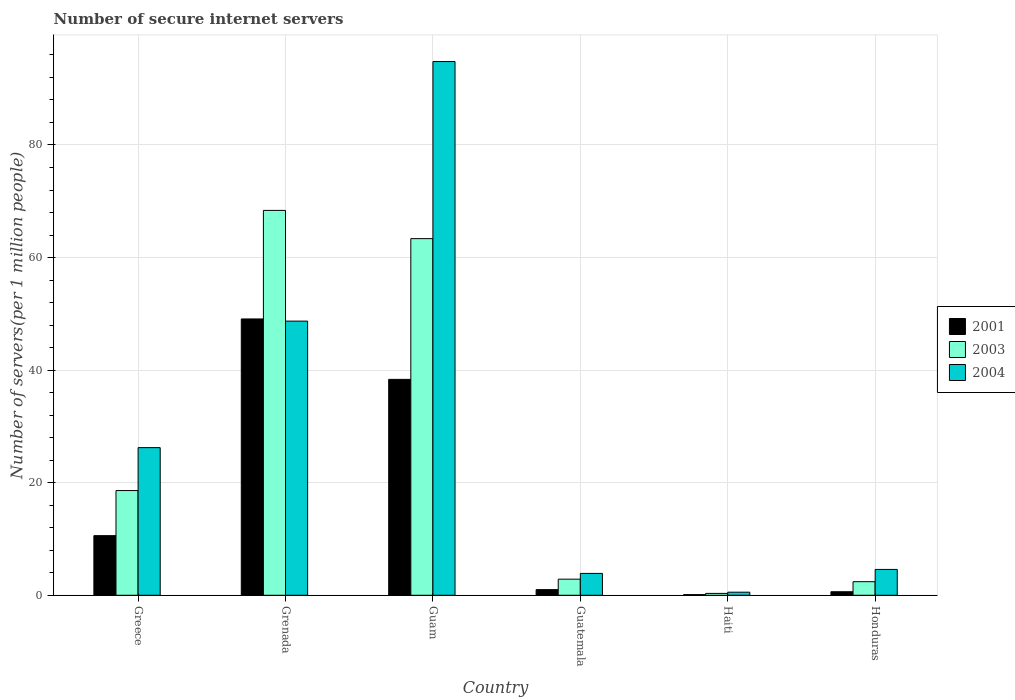Are the number of bars per tick equal to the number of legend labels?
Keep it short and to the point. Yes. Are the number of bars on each tick of the X-axis equal?
Make the answer very short. Yes. How many bars are there on the 4th tick from the left?
Provide a short and direct response. 3. How many bars are there on the 5th tick from the right?
Your response must be concise. 3. What is the label of the 3rd group of bars from the left?
Give a very brief answer. Guam. What is the number of secure internet servers in 2004 in Grenada?
Your answer should be very brief. 48.71. Across all countries, what is the maximum number of secure internet servers in 2001?
Offer a very short reply. 49.09. Across all countries, what is the minimum number of secure internet servers in 2001?
Provide a succinct answer. 0.12. In which country was the number of secure internet servers in 2001 maximum?
Offer a terse response. Grenada. In which country was the number of secure internet servers in 2004 minimum?
Your answer should be compact. Haiti. What is the total number of secure internet servers in 2004 in the graph?
Your response must be concise. 178.78. What is the difference between the number of secure internet servers in 2004 in Greece and that in Guam?
Your answer should be compact. -68.59. What is the difference between the number of secure internet servers in 2003 in Grenada and the number of secure internet servers in 2001 in Guam?
Your response must be concise. 30.02. What is the average number of secure internet servers in 2003 per country?
Offer a terse response. 25.99. What is the difference between the number of secure internet servers of/in 2003 and number of secure internet servers of/in 2001 in Guam?
Ensure brevity in your answer.  25. What is the ratio of the number of secure internet servers in 2001 in Haiti to that in Honduras?
Offer a very short reply. 0.18. Is the number of secure internet servers in 2004 in Grenada less than that in Guam?
Keep it short and to the point. Yes. What is the difference between the highest and the second highest number of secure internet servers in 2001?
Provide a succinct answer. 38.5. What is the difference between the highest and the lowest number of secure internet servers in 2003?
Give a very brief answer. 68.04. In how many countries, is the number of secure internet servers in 2003 greater than the average number of secure internet servers in 2003 taken over all countries?
Your answer should be compact. 2. Is the sum of the number of secure internet servers in 2003 in Guatemala and Haiti greater than the maximum number of secure internet servers in 2004 across all countries?
Provide a short and direct response. No. What does the 3rd bar from the left in Guatemala represents?
Your answer should be compact. 2004. What does the 2nd bar from the right in Guatemala represents?
Your response must be concise. 2003. What is the difference between two consecutive major ticks on the Y-axis?
Offer a terse response. 20. Are the values on the major ticks of Y-axis written in scientific E-notation?
Your answer should be compact. No. Where does the legend appear in the graph?
Make the answer very short. Center right. How many legend labels are there?
Offer a terse response. 3. How are the legend labels stacked?
Your answer should be compact. Vertical. What is the title of the graph?
Your answer should be very brief. Number of secure internet servers. What is the label or title of the X-axis?
Provide a succinct answer. Country. What is the label or title of the Y-axis?
Your answer should be very brief. Number of servers(per 1 million people). What is the Number of servers(per 1 million people) in 2001 in Greece?
Your response must be concise. 10.59. What is the Number of servers(per 1 million people) of 2003 in Greece?
Offer a terse response. 18.61. What is the Number of servers(per 1 million people) in 2004 in Greece?
Your response must be concise. 26.23. What is the Number of servers(per 1 million people) of 2001 in Grenada?
Ensure brevity in your answer.  49.09. What is the Number of servers(per 1 million people) of 2003 in Grenada?
Offer a terse response. 68.38. What is the Number of servers(per 1 million people) of 2004 in Grenada?
Keep it short and to the point. 48.71. What is the Number of servers(per 1 million people) of 2001 in Guam?
Your answer should be very brief. 38.36. What is the Number of servers(per 1 million people) in 2003 in Guam?
Ensure brevity in your answer.  63.36. What is the Number of servers(per 1 million people) of 2004 in Guam?
Your response must be concise. 94.82. What is the Number of servers(per 1 million people) in 2001 in Guatemala?
Offer a terse response. 1. What is the Number of servers(per 1 million people) of 2003 in Guatemala?
Your answer should be very brief. 2.86. What is the Number of servers(per 1 million people) of 2004 in Guatemala?
Provide a succinct answer. 3.88. What is the Number of servers(per 1 million people) of 2001 in Haiti?
Give a very brief answer. 0.12. What is the Number of servers(per 1 million people) of 2003 in Haiti?
Give a very brief answer. 0.33. What is the Number of servers(per 1 million people) of 2004 in Haiti?
Your answer should be very brief. 0.55. What is the Number of servers(per 1 million people) in 2001 in Honduras?
Make the answer very short. 0.63. What is the Number of servers(per 1 million people) of 2003 in Honduras?
Give a very brief answer. 2.41. What is the Number of servers(per 1 million people) in 2004 in Honduras?
Provide a succinct answer. 4.59. Across all countries, what is the maximum Number of servers(per 1 million people) in 2001?
Make the answer very short. 49.09. Across all countries, what is the maximum Number of servers(per 1 million people) in 2003?
Offer a very short reply. 68.38. Across all countries, what is the maximum Number of servers(per 1 million people) of 2004?
Give a very brief answer. 94.82. Across all countries, what is the minimum Number of servers(per 1 million people) in 2001?
Give a very brief answer. 0.12. Across all countries, what is the minimum Number of servers(per 1 million people) of 2003?
Make the answer very short. 0.33. Across all countries, what is the minimum Number of servers(per 1 million people) in 2004?
Offer a terse response. 0.55. What is the total Number of servers(per 1 million people) of 2001 in the graph?
Keep it short and to the point. 99.79. What is the total Number of servers(per 1 million people) of 2003 in the graph?
Make the answer very short. 155.96. What is the total Number of servers(per 1 million people) of 2004 in the graph?
Keep it short and to the point. 178.78. What is the difference between the Number of servers(per 1 million people) of 2001 in Greece and that in Grenada?
Your response must be concise. -38.5. What is the difference between the Number of servers(per 1 million people) of 2003 in Greece and that in Grenada?
Ensure brevity in your answer.  -49.77. What is the difference between the Number of servers(per 1 million people) of 2004 in Greece and that in Grenada?
Offer a terse response. -22.48. What is the difference between the Number of servers(per 1 million people) in 2001 in Greece and that in Guam?
Give a very brief answer. -27.77. What is the difference between the Number of servers(per 1 million people) of 2003 in Greece and that in Guam?
Ensure brevity in your answer.  -44.76. What is the difference between the Number of servers(per 1 million people) of 2004 in Greece and that in Guam?
Your response must be concise. -68.59. What is the difference between the Number of servers(per 1 million people) in 2001 in Greece and that in Guatemala?
Ensure brevity in your answer.  9.59. What is the difference between the Number of servers(per 1 million people) of 2003 in Greece and that in Guatemala?
Offer a terse response. 15.74. What is the difference between the Number of servers(per 1 million people) in 2004 in Greece and that in Guatemala?
Ensure brevity in your answer.  22.35. What is the difference between the Number of servers(per 1 million people) in 2001 in Greece and that in Haiti?
Make the answer very short. 10.48. What is the difference between the Number of servers(per 1 million people) in 2003 in Greece and that in Haiti?
Ensure brevity in your answer.  18.27. What is the difference between the Number of servers(per 1 million people) in 2004 in Greece and that in Haiti?
Keep it short and to the point. 25.68. What is the difference between the Number of servers(per 1 million people) in 2001 in Greece and that in Honduras?
Provide a succinct answer. 9.96. What is the difference between the Number of servers(per 1 million people) in 2003 in Greece and that in Honduras?
Offer a very short reply. 16.19. What is the difference between the Number of servers(per 1 million people) in 2004 in Greece and that in Honduras?
Make the answer very short. 21.64. What is the difference between the Number of servers(per 1 million people) of 2001 in Grenada and that in Guam?
Offer a very short reply. 10.73. What is the difference between the Number of servers(per 1 million people) of 2003 in Grenada and that in Guam?
Provide a short and direct response. 5.02. What is the difference between the Number of servers(per 1 million people) of 2004 in Grenada and that in Guam?
Ensure brevity in your answer.  -46.11. What is the difference between the Number of servers(per 1 million people) in 2001 in Grenada and that in Guatemala?
Offer a terse response. 48.09. What is the difference between the Number of servers(per 1 million people) in 2003 in Grenada and that in Guatemala?
Provide a short and direct response. 65.52. What is the difference between the Number of servers(per 1 million people) in 2004 in Grenada and that in Guatemala?
Your answer should be compact. 44.82. What is the difference between the Number of servers(per 1 million people) of 2001 in Grenada and that in Haiti?
Your response must be concise. 48.98. What is the difference between the Number of servers(per 1 million people) of 2003 in Grenada and that in Haiti?
Give a very brief answer. 68.04. What is the difference between the Number of servers(per 1 million people) of 2004 in Grenada and that in Haiti?
Your answer should be compact. 48.16. What is the difference between the Number of servers(per 1 million people) in 2001 in Grenada and that in Honduras?
Provide a succinct answer. 48.46. What is the difference between the Number of servers(per 1 million people) in 2003 in Grenada and that in Honduras?
Make the answer very short. 65.96. What is the difference between the Number of servers(per 1 million people) of 2004 in Grenada and that in Honduras?
Offer a very short reply. 44.12. What is the difference between the Number of servers(per 1 million people) of 2001 in Guam and that in Guatemala?
Keep it short and to the point. 37.36. What is the difference between the Number of servers(per 1 million people) in 2003 in Guam and that in Guatemala?
Provide a short and direct response. 60.5. What is the difference between the Number of servers(per 1 million people) in 2004 in Guam and that in Guatemala?
Your answer should be very brief. 90.94. What is the difference between the Number of servers(per 1 million people) in 2001 in Guam and that in Haiti?
Provide a short and direct response. 38.24. What is the difference between the Number of servers(per 1 million people) in 2003 in Guam and that in Haiti?
Keep it short and to the point. 63.03. What is the difference between the Number of servers(per 1 million people) of 2004 in Guam and that in Haiti?
Ensure brevity in your answer.  94.27. What is the difference between the Number of servers(per 1 million people) in 2001 in Guam and that in Honduras?
Provide a short and direct response. 37.73. What is the difference between the Number of servers(per 1 million people) of 2003 in Guam and that in Honduras?
Make the answer very short. 60.95. What is the difference between the Number of servers(per 1 million people) of 2004 in Guam and that in Honduras?
Keep it short and to the point. 90.23. What is the difference between the Number of servers(per 1 million people) of 2001 in Guatemala and that in Haiti?
Provide a succinct answer. 0.89. What is the difference between the Number of servers(per 1 million people) in 2003 in Guatemala and that in Haiti?
Provide a succinct answer. 2.53. What is the difference between the Number of servers(per 1 million people) of 2004 in Guatemala and that in Haiti?
Offer a terse response. 3.33. What is the difference between the Number of servers(per 1 million people) in 2001 in Guatemala and that in Honduras?
Your answer should be very brief. 0.37. What is the difference between the Number of servers(per 1 million people) in 2003 in Guatemala and that in Honduras?
Give a very brief answer. 0.45. What is the difference between the Number of servers(per 1 million people) in 2004 in Guatemala and that in Honduras?
Make the answer very short. -0.71. What is the difference between the Number of servers(per 1 million people) in 2001 in Haiti and that in Honduras?
Your answer should be very brief. -0.51. What is the difference between the Number of servers(per 1 million people) in 2003 in Haiti and that in Honduras?
Ensure brevity in your answer.  -2.08. What is the difference between the Number of servers(per 1 million people) of 2004 in Haiti and that in Honduras?
Give a very brief answer. -4.04. What is the difference between the Number of servers(per 1 million people) of 2001 in Greece and the Number of servers(per 1 million people) of 2003 in Grenada?
Provide a succinct answer. -57.79. What is the difference between the Number of servers(per 1 million people) in 2001 in Greece and the Number of servers(per 1 million people) in 2004 in Grenada?
Offer a terse response. -38.11. What is the difference between the Number of servers(per 1 million people) of 2003 in Greece and the Number of servers(per 1 million people) of 2004 in Grenada?
Ensure brevity in your answer.  -30.1. What is the difference between the Number of servers(per 1 million people) of 2001 in Greece and the Number of servers(per 1 million people) of 2003 in Guam?
Your answer should be very brief. -52.77. What is the difference between the Number of servers(per 1 million people) of 2001 in Greece and the Number of servers(per 1 million people) of 2004 in Guam?
Provide a short and direct response. -84.23. What is the difference between the Number of servers(per 1 million people) in 2003 in Greece and the Number of servers(per 1 million people) in 2004 in Guam?
Offer a terse response. -76.21. What is the difference between the Number of servers(per 1 million people) in 2001 in Greece and the Number of servers(per 1 million people) in 2003 in Guatemala?
Give a very brief answer. 7.73. What is the difference between the Number of servers(per 1 million people) in 2001 in Greece and the Number of servers(per 1 million people) in 2004 in Guatemala?
Offer a very short reply. 6.71. What is the difference between the Number of servers(per 1 million people) of 2003 in Greece and the Number of servers(per 1 million people) of 2004 in Guatemala?
Your answer should be compact. 14.72. What is the difference between the Number of servers(per 1 million people) of 2001 in Greece and the Number of servers(per 1 million people) of 2003 in Haiti?
Your answer should be very brief. 10.26. What is the difference between the Number of servers(per 1 million people) of 2001 in Greece and the Number of servers(per 1 million people) of 2004 in Haiti?
Keep it short and to the point. 10.04. What is the difference between the Number of servers(per 1 million people) of 2003 in Greece and the Number of servers(per 1 million people) of 2004 in Haiti?
Keep it short and to the point. 18.06. What is the difference between the Number of servers(per 1 million people) of 2001 in Greece and the Number of servers(per 1 million people) of 2003 in Honduras?
Offer a very short reply. 8.18. What is the difference between the Number of servers(per 1 million people) of 2001 in Greece and the Number of servers(per 1 million people) of 2004 in Honduras?
Provide a short and direct response. 6. What is the difference between the Number of servers(per 1 million people) in 2003 in Greece and the Number of servers(per 1 million people) in 2004 in Honduras?
Your response must be concise. 14.02. What is the difference between the Number of servers(per 1 million people) in 2001 in Grenada and the Number of servers(per 1 million people) in 2003 in Guam?
Your response must be concise. -14.27. What is the difference between the Number of servers(per 1 million people) in 2001 in Grenada and the Number of servers(per 1 million people) in 2004 in Guam?
Provide a short and direct response. -45.73. What is the difference between the Number of servers(per 1 million people) of 2003 in Grenada and the Number of servers(per 1 million people) of 2004 in Guam?
Offer a terse response. -26.44. What is the difference between the Number of servers(per 1 million people) of 2001 in Grenada and the Number of servers(per 1 million people) of 2003 in Guatemala?
Make the answer very short. 46.23. What is the difference between the Number of servers(per 1 million people) in 2001 in Grenada and the Number of servers(per 1 million people) in 2004 in Guatemala?
Keep it short and to the point. 45.21. What is the difference between the Number of servers(per 1 million people) in 2003 in Grenada and the Number of servers(per 1 million people) in 2004 in Guatemala?
Offer a terse response. 64.5. What is the difference between the Number of servers(per 1 million people) of 2001 in Grenada and the Number of servers(per 1 million people) of 2003 in Haiti?
Ensure brevity in your answer.  48.76. What is the difference between the Number of servers(per 1 million people) of 2001 in Grenada and the Number of servers(per 1 million people) of 2004 in Haiti?
Make the answer very short. 48.54. What is the difference between the Number of servers(per 1 million people) in 2003 in Grenada and the Number of servers(per 1 million people) in 2004 in Haiti?
Give a very brief answer. 67.83. What is the difference between the Number of servers(per 1 million people) of 2001 in Grenada and the Number of servers(per 1 million people) of 2003 in Honduras?
Your response must be concise. 46.68. What is the difference between the Number of servers(per 1 million people) in 2001 in Grenada and the Number of servers(per 1 million people) in 2004 in Honduras?
Give a very brief answer. 44.5. What is the difference between the Number of servers(per 1 million people) of 2003 in Grenada and the Number of servers(per 1 million people) of 2004 in Honduras?
Offer a terse response. 63.79. What is the difference between the Number of servers(per 1 million people) in 2001 in Guam and the Number of servers(per 1 million people) in 2003 in Guatemala?
Provide a short and direct response. 35.5. What is the difference between the Number of servers(per 1 million people) in 2001 in Guam and the Number of servers(per 1 million people) in 2004 in Guatemala?
Give a very brief answer. 34.48. What is the difference between the Number of servers(per 1 million people) in 2003 in Guam and the Number of servers(per 1 million people) in 2004 in Guatemala?
Ensure brevity in your answer.  59.48. What is the difference between the Number of servers(per 1 million people) in 2001 in Guam and the Number of servers(per 1 million people) in 2003 in Haiti?
Give a very brief answer. 38.02. What is the difference between the Number of servers(per 1 million people) in 2001 in Guam and the Number of servers(per 1 million people) in 2004 in Haiti?
Your response must be concise. 37.81. What is the difference between the Number of servers(per 1 million people) of 2003 in Guam and the Number of servers(per 1 million people) of 2004 in Haiti?
Give a very brief answer. 62.81. What is the difference between the Number of servers(per 1 million people) in 2001 in Guam and the Number of servers(per 1 million people) in 2003 in Honduras?
Your response must be concise. 35.94. What is the difference between the Number of servers(per 1 million people) in 2001 in Guam and the Number of servers(per 1 million people) in 2004 in Honduras?
Your response must be concise. 33.77. What is the difference between the Number of servers(per 1 million people) of 2003 in Guam and the Number of servers(per 1 million people) of 2004 in Honduras?
Ensure brevity in your answer.  58.77. What is the difference between the Number of servers(per 1 million people) of 2001 in Guatemala and the Number of servers(per 1 million people) of 2003 in Haiti?
Ensure brevity in your answer.  0.67. What is the difference between the Number of servers(per 1 million people) in 2001 in Guatemala and the Number of servers(per 1 million people) in 2004 in Haiti?
Your answer should be compact. 0.45. What is the difference between the Number of servers(per 1 million people) in 2003 in Guatemala and the Number of servers(per 1 million people) in 2004 in Haiti?
Make the answer very short. 2.31. What is the difference between the Number of servers(per 1 million people) of 2001 in Guatemala and the Number of servers(per 1 million people) of 2003 in Honduras?
Offer a terse response. -1.41. What is the difference between the Number of servers(per 1 million people) of 2001 in Guatemala and the Number of servers(per 1 million people) of 2004 in Honduras?
Make the answer very short. -3.59. What is the difference between the Number of servers(per 1 million people) in 2003 in Guatemala and the Number of servers(per 1 million people) in 2004 in Honduras?
Provide a short and direct response. -1.73. What is the difference between the Number of servers(per 1 million people) in 2001 in Haiti and the Number of servers(per 1 million people) in 2003 in Honduras?
Your answer should be compact. -2.3. What is the difference between the Number of servers(per 1 million people) in 2001 in Haiti and the Number of servers(per 1 million people) in 2004 in Honduras?
Provide a succinct answer. -4.48. What is the difference between the Number of servers(per 1 million people) in 2003 in Haiti and the Number of servers(per 1 million people) in 2004 in Honduras?
Offer a terse response. -4.26. What is the average Number of servers(per 1 million people) in 2001 per country?
Your answer should be compact. 16.63. What is the average Number of servers(per 1 million people) of 2003 per country?
Offer a terse response. 25.99. What is the average Number of servers(per 1 million people) of 2004 per country?
Give a very brief answer. 29.8. What is the difference between the Number of servers(per 1 million people) in 2001 and Number of servers(per 1 million people) in 2003 in Greece?
Offer a very short reply. -8.01. What is the difference between the Number of servers(per 1 million people) in 2001 and Number of servers(per 1 million people) in 2004 in Greece?
Offer a very short reply. -15.64. What is the difference between the Number of servers(per 1 million people) in 2003 and Number of servers(per 1 million people) in 2004 in Greece?
Ensure brevity in your answer.  -7.63. What is the difference between the Number of servers(per 1 million people) of 2001 and Number of servers(per 1 million people) of 2003 in Grenada?
Provide a succinct answer. -19.29. What is the difference between the Number of servers(per 1 million people) of 2001 and Number of servers(per 1 million people) of 2004 in Grenada?
Your answer should be compact. 0.39. What is the difference between the Number of servers(per 1 million people) of 2003 and Number of servers(per 1 million people) of 2004 in Grenada?
Offer a very short reply. 19.67. What is the difference between the Number of servers(per 1 million people) in 2001 and Number of servers(per 1 million people) in 2003 in Guam?
Ensure brevity in your answer.  -25. What is the difference between the Number of servers(per 1 million people) of 2001 and Number of servers(per 1 million people) of 2004 in Guam?
Your answer should be compact. -56.46. What is the difference between the Number of servers(per 1 million people) of 2003 and Number of servers(per 1 million people) of 2004 in Guam?
Ensure brevity in your answer.  -31.46. What is the difference between the Number of servers(per 1 million people) in 2001 and Number of servers(per 1 million people) in 2003 in Guatemala?
Provide a short and direct response. -1.86. What is the difference between the Number of servers(per 1 million people) of 2001 and Number of servers(per 1 million people) of 2004 in Guatemala?
Offer a very short reply. -2.88. What is the difference between the Number of servers(per 1 million people) of 2003 and Number of servers(per 1 million people) of 2004 in Guatemala?
Make the answer very short. -1.02. What is the difference between the Number of servers(per 1 million people) in 2001 and Number of servers(per 1 million people) in 2003 in Haiti?
Provide a succinct answer. -0.22. What is the difference between the Number of servers(per 1 million people) of 2001 and Number of servers(per 1 million people) of 2004 in Haiti?
Provide a succinct answer. -0.43. What is the difference between the Number of servers(per 1 million people) in 2003 and Number of servers(per 1 million people) in 2004 in Haiti?
Give a very brief answer. -0.21. What is the difference between the Number of servers(per 1 million people) in 2001 and Number of servers(per 1 million people) in 2003 in Honduras?
Keep it short and to the point. -1.79. What is the difference between the Number of servers(per 1 million people) in 2001 and Number of servers(per 1 million people) in 2004 in Honduras?
Provide a short and direct response. -3.96. What is the difference between the Number of servers(per 1 million people) in 2003 and Number of servers(per 1 million people) in 2004 in Honduras?
Provide a succinct answer. -2.18. What is the ratio of the Number of servers(per 1 million people) of 2001 in Greece to that in Grenada?
Your response must be concise. 0.22. What is the ratio of the Number of servers(per 1 million people) in 2003 in Greece to that in Grenada?
Keep it short and to the point. 0.27. What is the ratio of the Number of servers(per 1 million people) of 2004 in Greece to that in Grenada?
Make the answer very short. 0.54. What is the ratio of the Number of servers(per 1 million people) of 2001 in Greece to that in Guam?
Provide a succinct answer. 0.28. What is the ratio of the Number of servers(per 1 million people) of 2003 in Greece to that in Guam?
Offer a very short reply. 0.29. What is the ratio of the Number of servers(per 1 million people) of 2004 in Greece to that in Guam?
Ensure brevity in your answer.  0.28. What is the ratio of the Number of servers(per 1 million people) in 2001 in Greece to that in Guatemala?
Provide a short and direct response. 10.57. What is the ratio of the Number of servers(per 1 million people) in 2003 in Greece to that in Guatemala?
Ensure brevity in your answer.  6.5. What is the ratio of the Number of servers(per 1 million people) of 2004 in Greece to that in Guatemala?
Offer a very short reply. 6.76. What is the ratio of the Number of servers(per 1 million people) of 2001 in Greece to that in Haiti?
Keep it short and to the point. 92.07. What is the ratio of the Number of servers(per 1 million people) of 2003 in Greece to that in Haiti?
Your answer should be compact. 55.67. What is the ratio of the Number of servers(per 1 million people) of 2004 in Greece to that in Haiti?
Provide a short and direct response. 47.84. What is the ratio of the Number of servers(per 1 million people) of 2001 in Greece to that in Honduras?
Offer a very short reply. 16.87. What is the ratio of the Number of servers(per 1 million people) in 2003 in Greece to that in Honduras?
Provide a short and direct response. 7.71. What is the ratio of the Number of servers(per 1 million people) in 2004 in Greece to that in Honduras?
Offer a very short reply. 5.71. What is the ratio of the Number of servers(per 1 million people) in 2001 in Grenada to that in Guam?
Provide a short and direct response. 1.28. What is the ratio of the Number of servers(per 1 million people) of 2003 in Grenada to that in Guam?
Your answer should be compact. 1.08. What is the ratio of the Number of servers(per 1 million people) of 2004 in Grenada to that in Guam?
Make the answer very short. 0.51. What is the ratio of the Number of servers(per 1 million people) of 2001 in Grenada to that in Guatemala?
Offer a very short reply. 49. What is the ratio of the Number of servers(per 1 million people) in 2003 in Grenada to that in Guatemala?
Your answer should be compact. 23.88. What is the ratio of the Number of servers(per 1 million people) in 2004 in Grenada to that in Guatemala?
Ensure brevity in your answer.  12.54. What is the ratio of the Number of servers(per 1 million people) of 2001 in Grenada to that in Haiti?
Make the answer very short. 426.74. What is the ratio of the Number of servers(per 1 million people) of 2003 in Grenada to that in Haiti?
Keep it short and to the point. 204.6. What is the ratio of the Number of servers(per 1 million people) of 2004 in Grenada to that in Haiti?
Keep it short and to the point. 88.83. What is the ratio of the Number of servers(per 1 million people) of 2001 in Grenada to that in Honduras?
Offer a terse response. 78.2. What is the ratio of the Number of servers(per 1 million people) of 2003 in Grenada to that in Honduras?
Give a very brief answer. 28.32. What is the ratio of the Number of servers(per 1 million people) in 2004 in Grenada to that in Honduras?
Offer a very short reply. 10.61. What is the ratio of the Number of servers(per 1 million people) in 2001 in Guam to that in Guatemala?
Your response must be concise. 38.28. What is the ratio of the Number of servers(per 1 million people) in 2003 in Guam to that in Guatemala?
Offer a very short reply. 22.13. What is the ratio of the Number of servers(per 1 million people) of 2004 in Guam to that in Guatemala?
Provide a succinct answer. 24.42. What is the ratio of the Number of servers(per 1 million people) in 2001 in Guam to that in Haiti?
Keep it short and to the point. 333.44. What is the ratio of the Number of servers(per 1 million people) in 2003 in Guam to that in Haiti?
Give a very brief answer. 189.59. What is the ratio of the Number of servers(per 1 million people) of 2004 in Guam to that in Haiti?
Provide a succinct answer. 172.94. What is the ratio of the Number of servers(per 1 million people) of 2001 in Guam to that in Honduras?
Your answer should be very brief. 61.1. What is the ratio of the Number of servers(per 1 million people) of 2003 in Guam to that in Honduras?
Offer a very short reply. 26.24. What is the ratio of the Number of servers(per 1 million people) in 2004 in Guam to that in Honduras?
Offer a terse response. 20.66. What is the ratio of the Number of servers(per 1 million people) in 2001 in Guatemala to that in Haiti?
Give a very brief answer. 8.71. What is the ratio of the Number of servers(per 1 million people) in 2003 in Guatemala to that in Haiti?
Provide a short and direct response. 8.57. What is the ratio of the Number of servers(per 1 million people) in 2004 in Guatemala to that in Haiti?
Provide a succinct answer. 7.08. What is the ratio of the Number of servers(per 1 million people) in 2001 in Guatemala to that in Honduras?
Provide a short and direct response. 1.6. What is the ratio of the Number of servers(per 1 million people) in 2003 in Guatemala to that in Honduras?
Provide a succinct answer. 1.19. What is the ratio of the Number of servers(per 1 million people) in 2004 in Guatemala to that in Honduras?
Offer a terse response. 0.85. What is the ratio of the Number of servers(per 1 million people) of 2001 in Haiti to that in Honduras?
Make the answer very short. 0.18. What is the ratio of the Number of servers(per 1 million people) of 2003 in Haiti to that in Honduras?
Provide a succinct answer. 0.14. What is the ratio of the Number of servers(per 1 million people) in 2004 in Haiti to that in Honduras?
Provide a short and direct response. 0.12. What is the difference between the highest and the second highest Number of servers(per 1 million people) in 2001?
Your answer should be very brief. 10.73. What is the difference between the highest and the second highest Number of servers(per 1 million people) in 2003?
Give a very brief answer. 5.02. What is the difference between the highest and the second highest Number of servers(per 1 million people) of 2004?
Offer a very short reply. 46.11. What is the difference between the highest and the lowest Number of servers(per 1 million people) in 2001?
Your response must be concise. 48.98. What is the difference between the highest and the lowest Number of servers(per 1 million people) in 2003?
Ensure brevity in your answer.  68.04. What is the difference between the highest and the lowest Number of servers(per 1 million people) of 2004?
Your response must be concise. 94.27. 